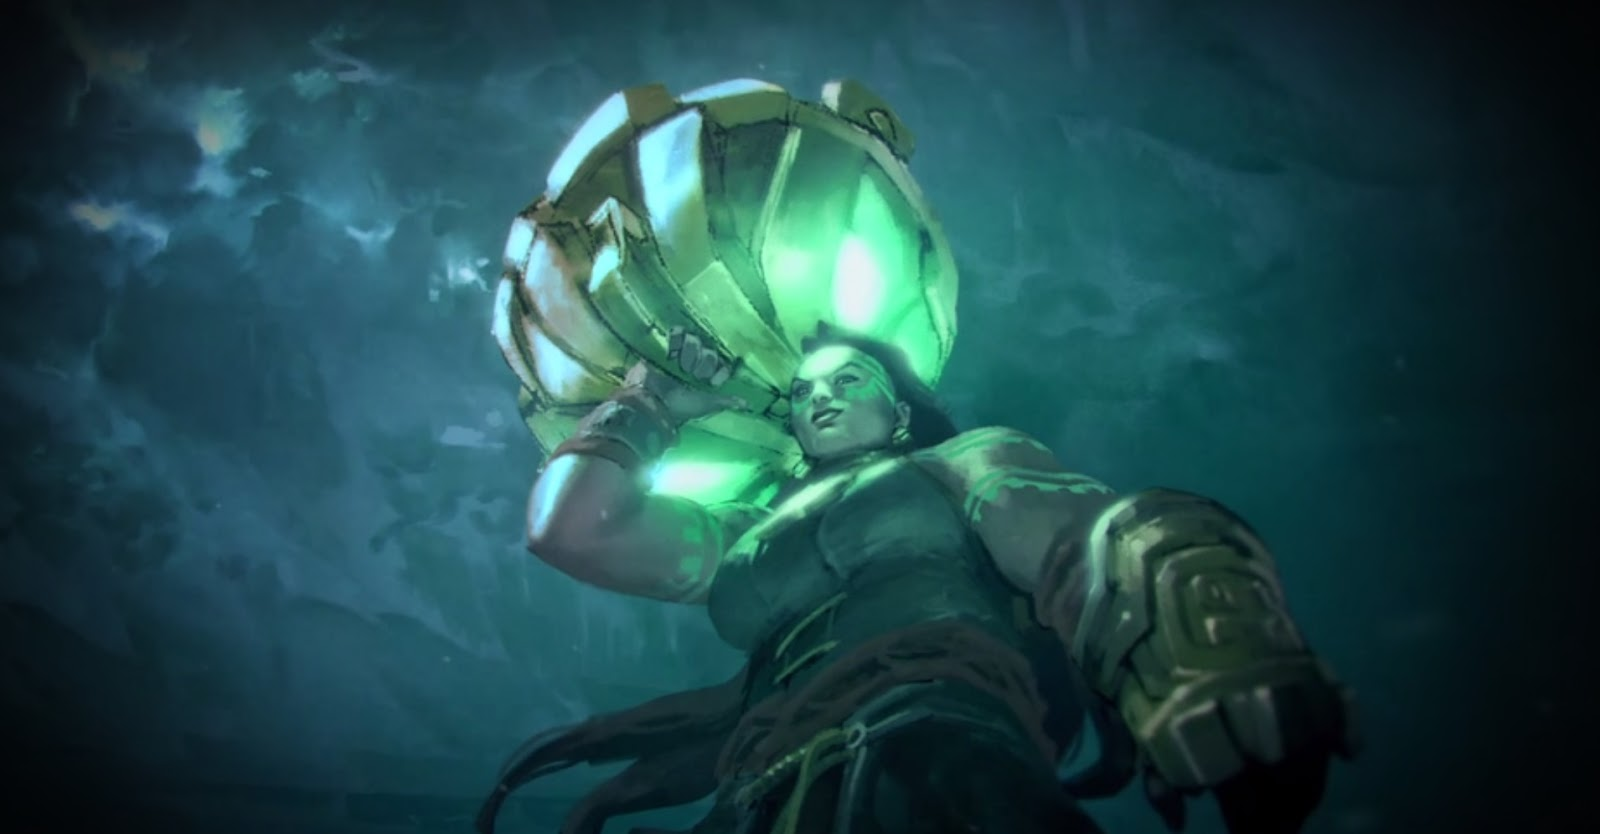Given the character's attire and environment, what kind of mission or activity could they be engaged in? The character, equipped with an advanced armored suit, seems to be undertaking an underwater mission. The robust suit design, complete with armored elements and integrated lighting, primarily suggests a deep-sea exploration mission aimed at investigating uncharted territories of the ocean floor. This could involve collecting geological or biological samples, studying oceanic anomalies, or mapping unexplored regions. The suit's sturdy design also hints that it could serve a dual purpose, providing necessary defense mechanisms in a potential combat scenario. This might include facing underwater threats, whether environmental or from other deep-sea entities. The serious expression and poised stance further suggest a mission with high stakes and substantial challenges. 